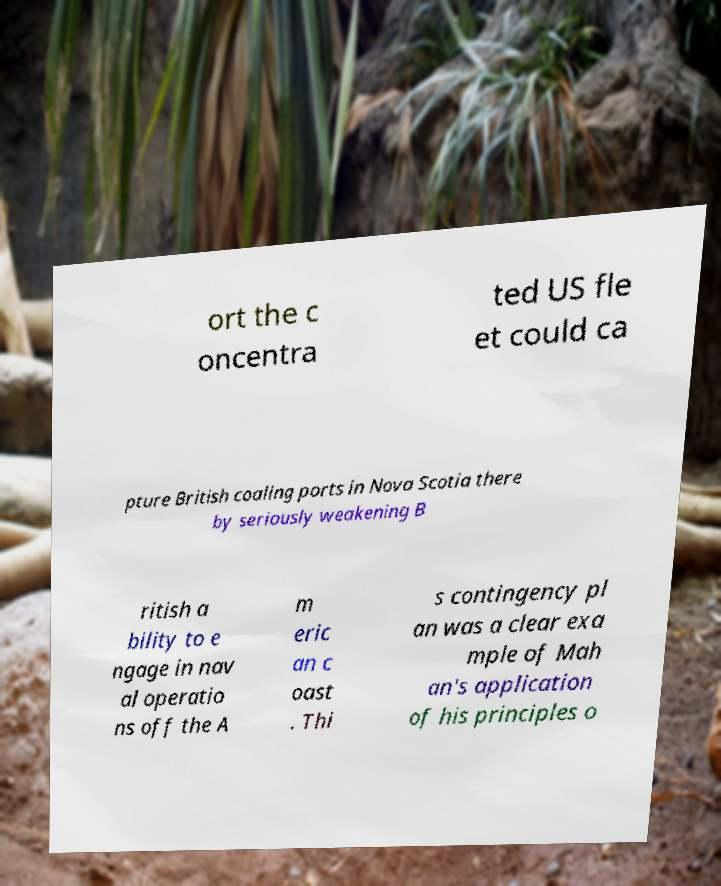Please identify and transcribe the text found in this image. ort the c oncentra ted US fle et could ca pture British coaling ports in Nova Scotia there by seriously weakening B ritish a bility to e ngage in nav al operatio ns off the A m eric an c oast . Thi s contingency pl an was a clear exa mple of Mah an's application of his principles o 